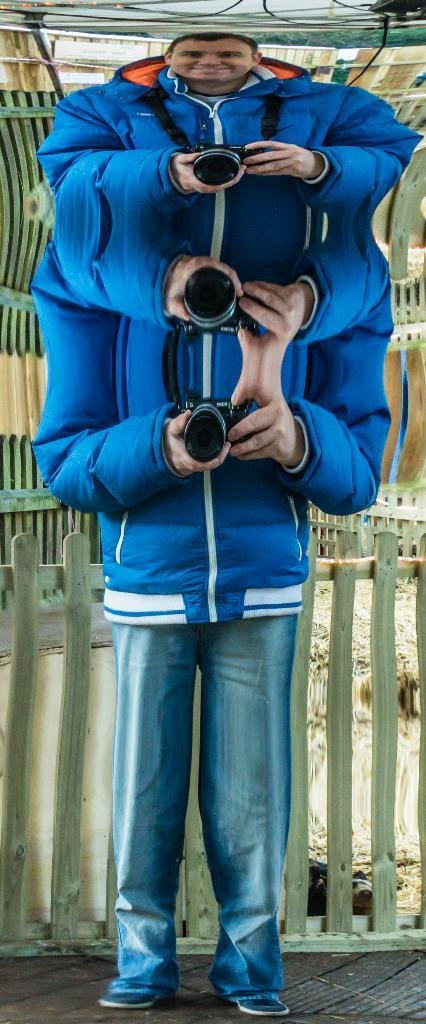Who is the main subject in the image? There is a person in the center of the image. What is the person holding in the image? The person is holding a camera. What can be seen in the background of the image? There is a fence in the background of the image. What is at the bottom of the image? There is a walkway at the bottom of the image. What type of net is being used to catch fish in the image? There is no net or fishing activity present in the image. What season is depicted in the image? The provided facts do not mention any seasonal elements, so it cannot be determined from the image. 